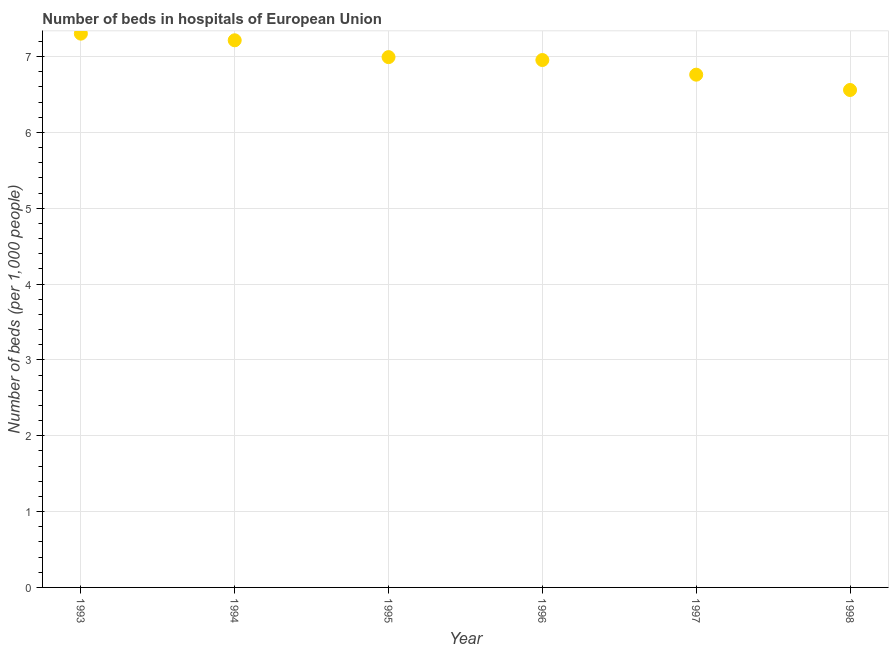What is the number of hospital beds in 1997?
Your response must be concise. 6.76. Across all years, what is the maximum number of hospital beds?
Provide a succinct answer. 7.3. Across all years, what is the minimum number of hospital beds?
Provide a succinct answer. 6.56. In which year was the number of hospital beds maximum?
Offer a terse response. 1993. What is the sum of the number of hospital beds?
Offer a very short reply. 41.79. What is the difference between the number of hospital beds in 1993 and 1994?
Your answer should be compact. 0.09. What is the average number of hospital beds per year?
Ensure brevity in your answer.  6.96. What is the median number of hospital beds?
Your answer should be compact. 6.97. What is the ratio of the number of hospital beds in 1993 to that in 1995?
Your answer should be compact. 1.04. Is the number of hospital beds in 1994 less than that in 1997?
Keep it short and to the point. No. Is the difference between the number of hospital beds in 1995 and 1996 greater than the difference between any two years?
Make the answer very short. No. What is the difference between the highest and the second highest number of hospital beds?
Ensure brevity in your answer.  0.09. Is the sum of the number of hospital beds in 1993 and 1997 greater than the maximum number of hospital beds across all years?
Your answer should be very brief. Yes. What is the difference between the highest and the lowest number of hospital beds?
Offer a very short reply. 0.74. In how many years, is the number of hospital beds greater than the average number of hospital beds taken over all years?
Provide a succinct answer. 3. Does the number of hospital beds monotonically increase over the years?
Provide a succinct answer. No. How many dotlines are there?
Ensure brevity in your answer.  1. How many years are there in the graph?
Your answer should be very brief. 6. Are the values on the major ticks of Y-axis written in scientific E-notation?
Ensure brevity in your answer.  No. Does the graph contain any zero values?
Offer a very short reply. No. Does the graph contain grids?
Your response must be concise. Yes. What is the title of the graph?
Give a very brief answer. Number of beds in hospitals of European Union. What is the label or title of the X-axis?
Your answer should be compact. Year. What is the label or title of the Y-axis?
Your answer should be very brief. Number of beds (per 1,0 people). What is the Number of beds (per 1,000 people) in 1993?
Ensure brevity in your answer.  7.3. What is the Number of beds (per 1,000 people) in 1994?
Your answer should be very brief. 7.22. What is the Number of beds (per 1,000 people) in 1995?
Keep it short and to the point. 6.99. What is the Number of beds (per 1,000 people) in 1996?
Provide a short and direct response. 6.95. What is the Number of beds (per 1,000 people) in 1997?
Ensure brevity in your answer.  6.76. What is the Number of beds (per 1,000 people) in 1998?
Keep it short and to the point. 6.56. What is the difference between the Number of beds (per 1,000 people) in 1993 and 1994?
Make the answer very short. 0.09. What is the difference between the Number of beds (per 1,000 people) in 1993 and 1995?
Offer a very short reply. 0.31. What is the difference between the Number of beds (per 1,000 people) in 1993 and 1996?
Keep it short and to the point. 0.35. What is the difference between the Number of beds (per 1,000 people) in 1993 and 1997?
Your answer should be very brief. 0.54. What is the difference between the Number of beds (per 1,000 people) in 1993 and 1998?
Provide a succinct answer. 0.74. What is the difference between the Number of beds (per 1,000 people) in 1994 and 1995?
Ensure brevity in your answer.  0.22. What is the difference between the Number of beds (per 1,000 people) in 1994 and 1996?
Offer a very short reply. 0.26. What is the difference between the Number of beds (per 1,000 people) in 1994 and 1997?
Your answer should be very brief. 0.45. What is the difference between the Number of beds (per 1,000 people) in 1994 and 1998?
Provide a short and direct response. 0.66. What is the difference between the Number of beds (per 1,000 people) in 1995 and 1996?
Keep it short and to the point. 0.04. What is the difference between the Number of beds (per 1,000 people) in 1995 and 1997?
Provide a short and direct response. 0.23. What is the difference between the Number of beds (per 1,000 people) in 1995 and 1998?
Ensure brevity in your answer.  0.43. What is the difference between the Number of beds (per 1,000 people) in 1996 and 1997?
Provide a short and direct response. 0.19. What is the difference between the Number of beds (per 1,000 people) in 1996 and 1998?
Your response must be concise. 0.4. What is the difference between the Number of beds (per 1,000 people) in 1997 and 1998?
Ensure brevity in your answer.  0.2. What is the ratio of the Number of beds (per 1,000 people) in 1993 to that in 1994?
Offer a very short reply. 1.01. What is the ratio of the Number of beds (per 1,000 people) in 1993 to that in 1995?
Provide a short and direct response. 1.04. What is the ratio of the Number of beds (per 1,000 people) in 1993 to that in 1996?
Make the answer very short. 1.05. What is the ratio of the Number of beds (per 1,000 people) in 1993 to that in 1997?
Offer a terse response. 1.08. What is the ratio of the Number of beds (per 1,000 people) in 1993 to that in 1998?
Provide a succinct answer. 1.11. What is the ratio of the Number of beds (per 1,000 people) in 1994 to that in 1995?
Provide a succinct answer. 1.03. What is the ratio of the Number of beds (per 1,000 people) in 1994 to that in 1996?
Your response must be concise. 1.04. What is the ratio of the Number of beds (per 1,000 people) in 1994 to that in 1997?
Your answer should be very brief. 1.07. What is the ratio of the Number of beds (per 1,000 people) in 1994 to that in 1998?
Your answer should be compact. 1.1. What is the ratio of the Number of beds (per 1,000 people) in 1995 to that in 1997?
Provide a short and direct response. 1.03. What is the ratio of the Number of beds (per 1,000 people) in 1995 to that in 1998?
Provide a succinct answer. 1.07. What is the ratio of the Number of beds (per 1,000 people) in 1996 to that in 1998?
Offer a terse response. 1.06. What is the ratio of the Number of beds (per 1,000 people) in 1997 to that in 1998?
Your answer should be very brief. 1.03. 